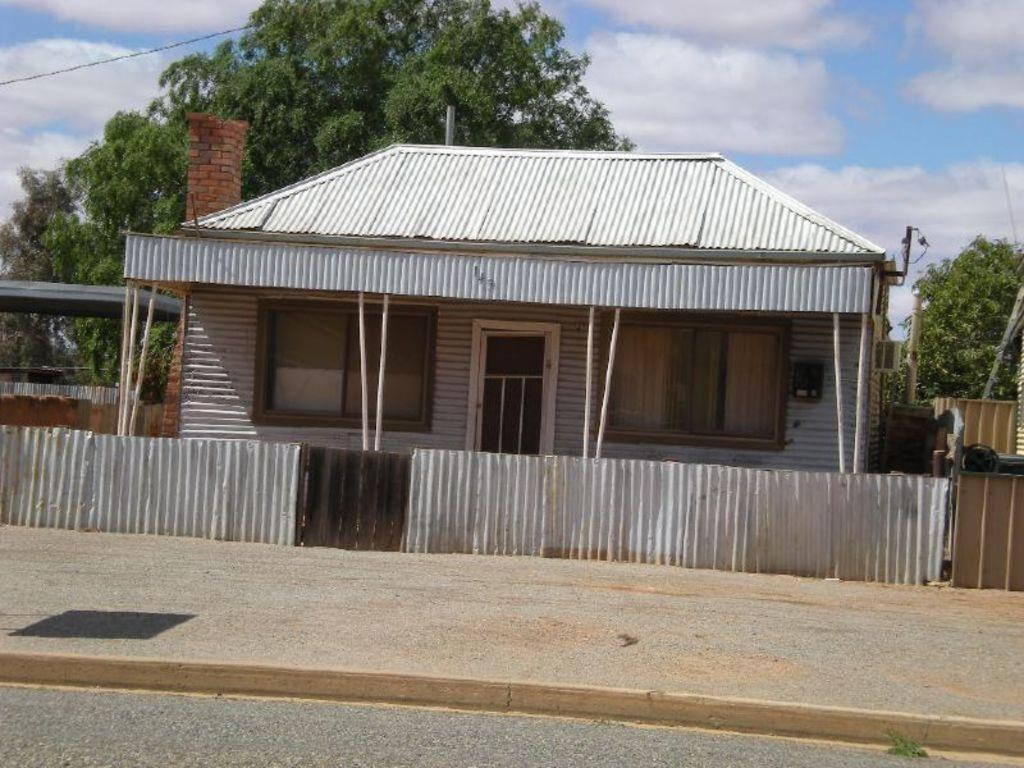What type of structure is visible in the image? There is a house in the image. What other structure can be seen near the house? There is a shed in the image. What type of vegetation is visible behind the house? There are trees behind the house. What utility is visible in the image? There is a cable visible in the image. What part of the natural environment is visible in the image? The sky is visible in the image. What type of bread is being used to support the stem in the image? There is no bread or stem present in the image. 